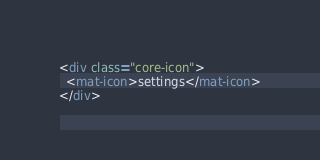Convert code to text. <code><loc_0><loc_0><loc_500><loc_500><_HTML_><div class="core-icon">
  <mat-icon>settings</mat-icon>
</div>
</code> 